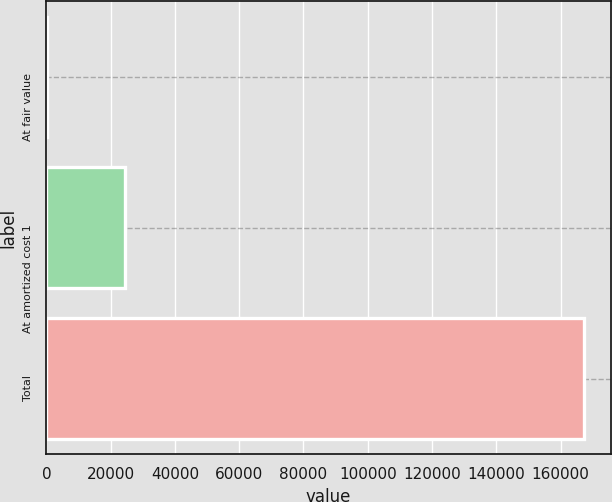Convert chart to OTSL. <chart><loc_0><loc_0><loc_500><loc_500><bar_chart><fcel>At fair value<fcel>At amortized cost 1<fcel>Total<nl><fcel>122<fcel>24547<fcel>167305<nl></chart> 